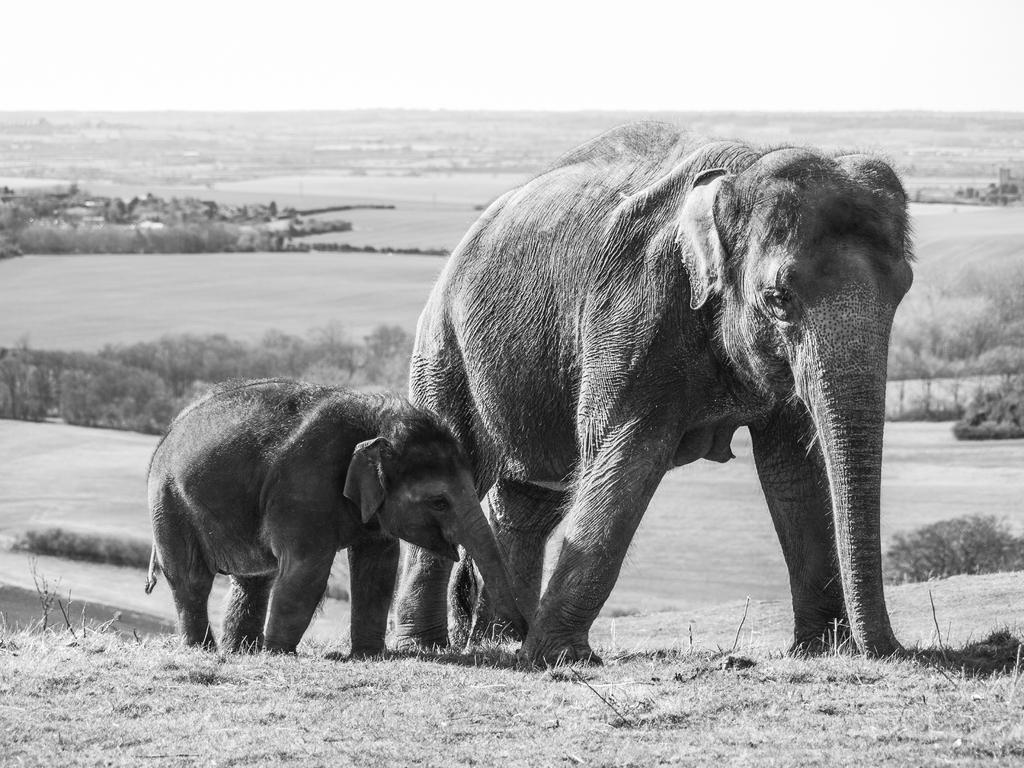Could you give a brief overview of what you see in this image? In this image there is an elephant and a baby elephant are walking, behind them there are trees. 